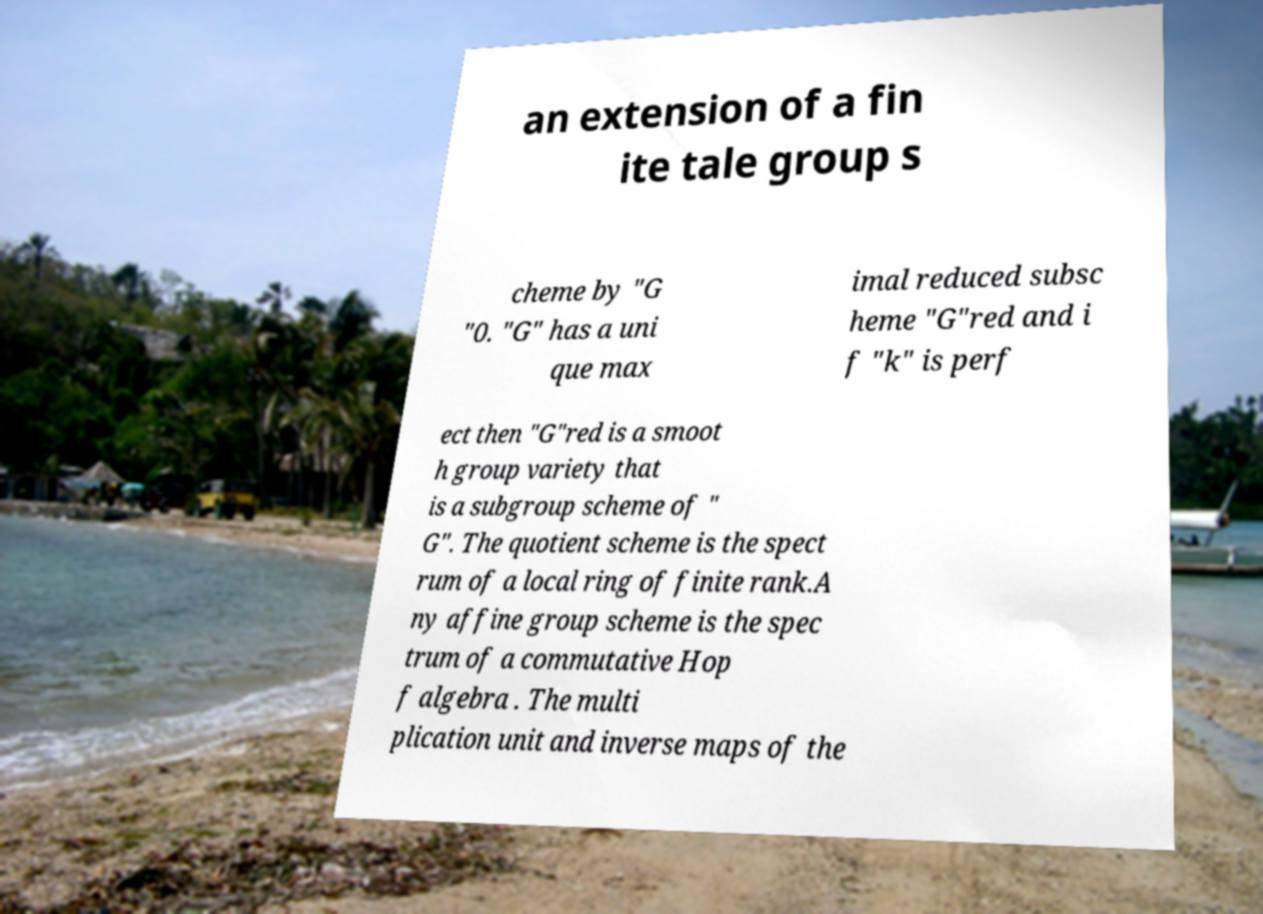Please read and relay the text visible in this image. What does it say? an extension of a fin ite tale group s cheme by "G "0. "G" has a uni que max imal reduced subsc heme "G"red and i f "k" is perf ect then "G"red is a smoot h group variety that is a subgroup scheme of " G". The quotient scheme is the spect rum of a local ring of finite rank.A ny affine group scheme is the spec trum of a commutative Hop f algebra . The multi plication unit and inverse maps of the 